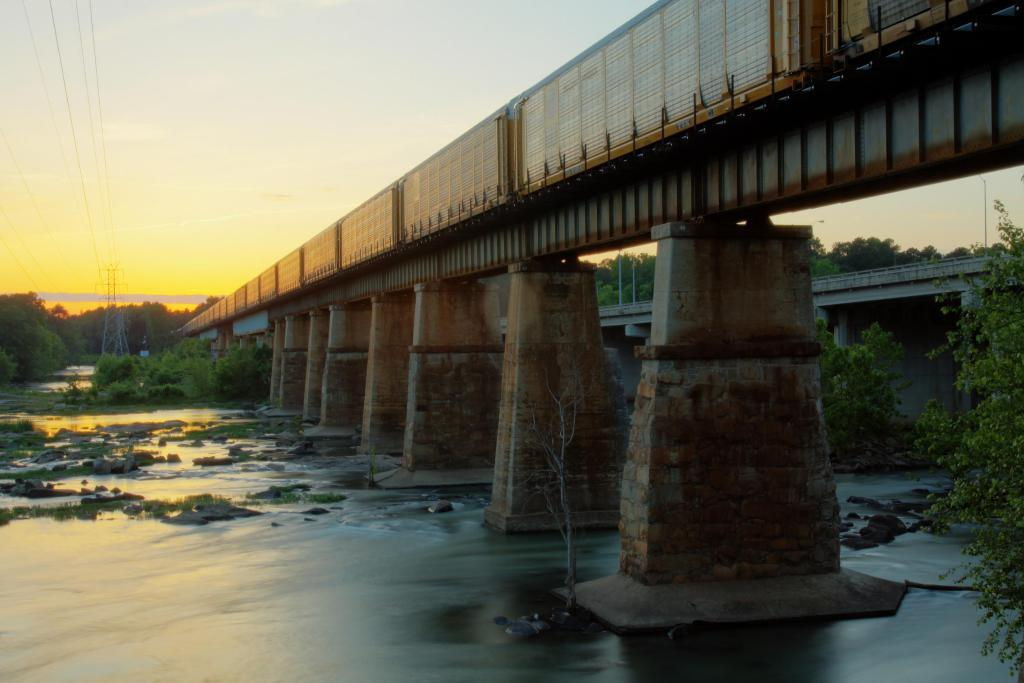What structure can be seen in the image? There is a bridge in the image. What is under the bridge? There is water under the bridge. What type of lighting is present on the bridge? There are street lights on the bridge. What can be seen in the background of the image? There is a tower and wires in the background of the image. What type of education is being offered by the bridge in the image? The bridge in the image is not offering any education; it is a structure for crossing water. 